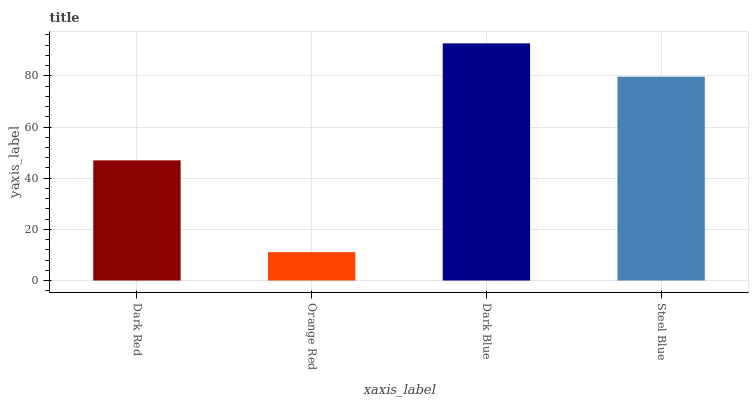Is Orange Red the minimum?
Answer yes or no. Yes. Is Dark Blue the maximum?
Answer yes or no. Yes. Is Dark Blue the minimum?
Answer yes or no. No. Is Orange Red the maximum?
Answer yes or no. No. Is Dark Blue greater than Orange Red?
Answer yes or no. Yes. Is Orange Red less than Dark Blue?
Answer yes or no. Yes. Is Orange Red greater than Dark Blue?
Answer yes or no. No. Is Dark Blue less than Orange Red?
Answer yes or no. No. Is Steel Blue the high median?
Answer yes or no. Yes. Is Dark Red the low median?
Answer yes or no. Yes. Is Dark Blue the high median?
Answer yes or no. No. Is Steel Blue the low median?
Answer yes or no. No. 